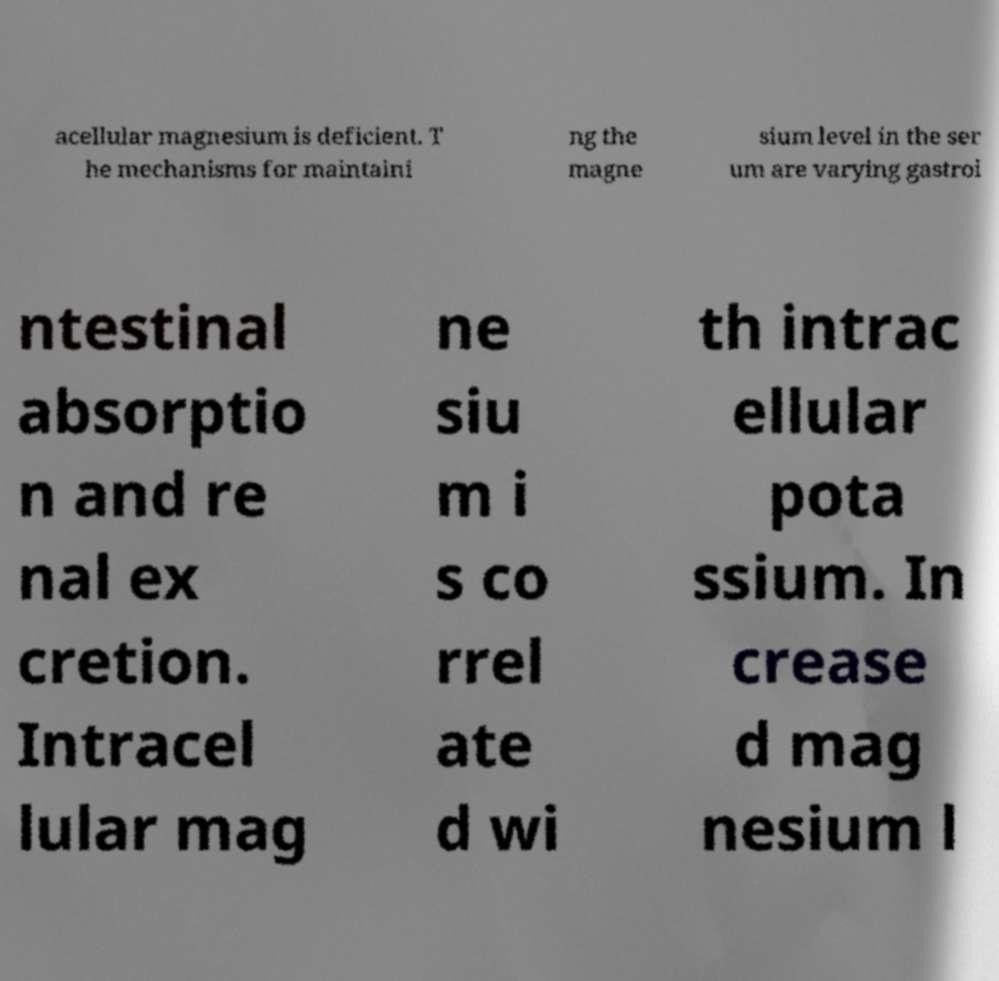What messages or text are displayed in this image? I need them in a readable, typed format. acellular magnesium is deficient. T he mechanisms for maintaini ng the magne sium level in the ser um are varying gastroi ntestinal absorptio n and re nal ex cretion. Intracel lular mag ne siu m i s co rrel ate d wi th intrac ellular pota ssium. In crease d mag nesium l 